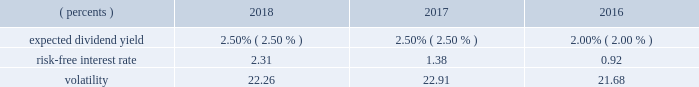Shareholder value award program svas are granted to officers and management and are payable in shares of our common stock .
The number of shares actually issued , if any , varies depending on our stock price at the end of the three-year vesting period compared to pre-established target stock prices .
We measure the fair value of the sva unit on the grant date using a monte carlo simulation model .
The model utilizes multiple input variables that determine the probability of satisfying the market condition stipulated in the award grant and calculates the fair value of the award .
Expected volatilities utilized in the model are based on implied volatilities from traded options on our stock , historical volatility of our stock price , and other factors .
Similarly , the dividend yield is based on historical experience and our estimate of future dividend yields .
The risk-free interest rate is derived from the u.s .
Treasury yield curve in effect at the time of grant .
The weighted-average fair values of the sva units granted during the years ended december 31 , 2018 , 2017 , and 2016 were $ 48.51 , $ 66.25 , and $ 48.68 , respectively , determined using the following assumptions: .
Pursuant to this program , approximately 0.7 million shares , 1.1 million shares , and 1.0 million shares were issued during the years ended december 31 , 2018 , 2017 , and 2016 , respectively .
Approximately 1.0 million shares are expected to be issued in 2019 .
As of december 31 , 2018 , the total remaining unrecognized compensation cost related to nonvested svas was $ 55.7 million , which will be amortized over the weighted-average remaining requisite service period of 20 months .
Restricted stock units rsus are granted to certain employees and are payable in shares of our common stock .
Rsu shares are accounted for at fair value based upon the closing stock price on the date of grant .
The corresponding expense is amortized over the vesting period , typically three years .
The fair values of rsu awards granted during the years ended december 31 , 2018 , 2017 , and 2016 were $ 70.95 , $ 72.47 , and $ 71.46 , respectively .
The number of shares ultimately issued for the rsu program remains constant with the exception of forfeitures .
Pursuant to this program , 1.3 million , 1.4 million , and 1.3 million shares were granted and approximately 1.0 million , 0.9 million , and 0.6 million shares were issued during the years ended december 31 , 2018 , 2017 , and 2016 , respectively .
Approximately 0.8 million shares are expected to be issued in 2019 .
As of december 31 , 2018 , the total remaining unrecognized compensation cost related to nonvested rsus was $ 112.2 million , which will be amortized over the weighted- average remaining requisite service period of 21 months .
Note 12 : shareholders' equity during 2018 , 2017 , and 2016 , we repurchased $ 4.15 billion , $ 359.8 million and $ 540.1 million , respectively , of shares associated with our share repurchase programs .
A payment of $ 60.0 million was made in 2016 for shares repurchased in 2017 .
During 2018 , we repurchased $ 2.05 billion of shares , which completed the $ 5.00 billion share repurchase program announced in october 2013 and our board authorized an $ 8.00 billion share repurchase program .
There were $ 2.10 billion repurchased under the $ 8.00 billion program in 2018 .
As of december 31 , 2018 , there were $ 5.90 billion of shares remaining under the 2018 program .
We have 5.0 million authorized shares of preferred stock .
As of december 31 , 2018 and 2017 , no preferred stock was issued .
We have an employee benefit trust that held 50.0 million shares of our common stock at both december 31 , 2018 and 2017 , to provide a source of funds to assist us in meeting our obligations under various employee benefit plans .
The cost basis of the shares held in the trust was $ 3.01 billion at both december 31 , 2018 and 2017 , and is shown as a reduction of shareholders 2019 equity .
Any dividend transactions between us and the trust are eliminated .
Stock held by the trust is not considered outstanding in the computation of eps .
The assets of the trust were not used to fund any of our obligations under these employee benefit plans during the years ended december 31 , 2018 , 2017 , and .
What was the percent of the change in the fair values of rsu awards granted from 2016 to 2017? 
Rationale: the percent of the change in the fair values of rsu awards granted from 2016 to 2017 was 1.4%
Computations: (1.1 / 71.46)
Answer: 0.01539. Shareholder value award program svas are granted to officers and management and are payable in shares of our common stock .
The number of shares actually issued , if any , varies depending on our stock price at the end of the three-year vesting period compared to pre-established target stock prices .
We measure the fair value of the sva unit on the grant date using a monte carlo simulation model .
The model utilizes multiple input variables that determine the probability of satisfying the market condition stipulated in the award grant and calculates the fair value of the award .
Expected volatilities utilized in the model are based on implied volatilities from traded options on our stock , historical volatility of our stock price , and other factors .
Similarly , the dividend yield is based on historical experience and our estimate of future dividend yields .
The risk-free interest rate is derived from the u.s .
Treasury yield curve in effect at the time of grant .
The weighted-average fair values of the sva units granted during the years ended december 31 , 2018 , 2017 , and 2016 were $ 48.51 , $ 66.25 , and $ 48.68 , respectively , determined using the following assumptions: .
Pursuant to this program , approximately 0.7 million shares , 1.1 million shares , and 1.0 million shares were issued during the years ended december 31 , 2018 , 2017 , and 2016 , respectively .
Approximately 1.0 million shares are expected to be issued in 2019 .
As of december 31 , 2018 , the total remaining unrecognized compensation cost related to nonvested svas was $ 55.7 million , which will be amortized over the weighted-average remaining requisite service period of 20 months .
Restricted stock units rsus are granted to certain employees and are payable in shares of our common stock .
Rsu shares are accounted for at fair value based upon the closing stock price on the date of grant .
The corresponding expense is amortized over the vesting period , typically three years .
The fair values of rsu awards granted during the years ended december 31 , 2018 , 2017 , and 2016 were $ 70.95 , $ 72.47 , and $ 71.46 , respectively .
The number of shares ultimately issued for the rsu program remains constant with the exception of forfeitures .
Pursuant to this program , 1.3 million , 1.4 million , and 1.3 million shares were granted and approximately 1.0 million , 0.9 million , and 0.6 million shares were issued during the years ended december 31 , 2018 , 2017 , and 2016 , respectively .
Approximately 0.8 million shares are expected to be issued in 2019 .
As of december 31 , 2018 , the total remaining unrecognized compensation cost related to nonvested rsus was $ 112.2 million , which will be amortized over the weighted- average remaining requisite service period of 21 months .
Note 12 : shareholders' equity during 2018 , 2017 , and 2016 , we repurchased $ 4.15 billion , $ 359.8 million and $ 540.1 million , respectively , of shares associated with our share repurchase programs .
A payment of $ 60.0 million was made in 2016 for shares repurchased in 2017 .
During 2018 , we repurchased $ 2.05 billion of shares , which completed the $ 5.00 billion share repurchase program announced in october 2013 and our board authorized an $ 8.00 billion share repurchase program .
There were $ 2.10 billion repurchased under the $ 8.00 billion program in 2018 .
As of december 31 , 2018 , there were $ 5.90 billion of shares remaining under the 2018 program .
We have 5.0 million authorized shares of preferred stock .
As of december 31 , 2018 and 2017 , no preferred stock was issued .
We have an employee benefit trust that held 50.0 million shares of our common stock at both december 31 , 2018 and 2017 , to provide a source of funds to assist us in meeting our obligations under various employee benefit plans .
The cost basis of the shares held in the trust was $ 3.01 billion at both december 31 , 2018 and 2017 , and is shown as a reduction of shareholders 2019 equity .
Any dividend transactions between us and the trust are eliminated .
Stock held by the trust is not considered outstanding in the computation of eps .
The assets of the trust were not used to fund any of our obligations under these employee benefit plans during the years ended december 31 , 2018 , 2017 , and .
What was the percentage change in dollars spent on share repurchase between 2016 and 2017? 
Computations: ((359.8 - 540.1) / 540.1)
Answer: -0.33383. Shareholder value award program svas are granted to officers and management and are payable in shares of our common stock .
The number of shares actually issued , if any , varies depending on our stock price at the end of the three-year vesting period compared to pre-established target stock prices .
We measure the fair value of the sva unit on the grant date using a monte carlo simulation model .
The model utilizes multiple input variables that determine the probability of satisfying the market condition stipulated in the award grant and calculates the fair value of the award .
Expected volatilities utilized in the model are based on implied volatilities from traded options on our stock , historical volatility of our stock price , and other factors .
Similarly , the dividend yield is based on historical experience and our estimate of future dividend yields .
The risk-free interest rate is derived from the u.s .
Treasury yield curve in effect at the time of grant .
The weighted-average fair values of the sva units granted during the years ended december 31 , 2018 , 2017 , and 2016 were $ 48.51 , $ 66.25 , and $ 48.68 , respectively , determined using the following assumptions: .
Pursuant to this program , approximately 0.7 million shares , 1.1 million shares , and 1.0 million shares were issued during the years ended december 31 , 2018 , 2017 , and 2016 , respectively .
Approximately 1.0 million shares are expected to be issued in 2019 .
As of december 31 , 2018 , the total remaining unrecognized compensation cost related to nonvested svas was $ 55.7 million , which will be amortized over the weighted-average remaining requisite service period of 20 months .
Restricted stock units rsus are granted to certain employees and are payable in shares of our common stock .
Rsu shares are accounted for at fair value based upon the closing stock price on the date of grant .
The corresponding expense is amortized over the vesting period , typically three years .
The fair values of rsu awards granted during the years ended december 31 , 2018 , 2017 , and 2016 were $ 70.95 , $ 72.47 , and $ 71.46 , respectively .
The number of shares ultimately issued for the rsu program remains constant with the exception of forfeitures .
Pursuant to this program , 1.3 million , 1.4 million , and 1.3 million shares were granted and approximately 1.0 million , 0.9 million , and 0.6 million shares were issued during the years ended december 31 , 2018 , 2017 , and 2016 , respectively .
Approximately 0.8 million shares are expected to be issued in 2019 .
As of december 31 , 2018 , the total remaining unrecognized compensation cost related to nonvested rsus was $ 112.2 million , which will be amortized over the weighted- average remaining requisite service period of 21 months .
Note 12 : shareholders' equity during 2018 , 2017 , and 2016 , we repurchased $ 4.15 billion , $ 359.8 million and $ 540.1 million , respectively , of shares associated with our share repurchase programs .
A payment of $ 60.0 million was made in 2016 for shares repurchased in 2017 .
During 2018 , we repurchased $ 2.05 billion of shares , which completed the $ 5.00 billion share repurchase program announced in october 2013 and our board authorized an $ 8.00 billion share repurchase program .
There were $ 2.10 billion repurchased under the $ 8.00 billion program in 2018 .
As of december 31 , 2018 , there were $ 5.90 billion of shares remaining under the 2018 program .
We have 5.0 million authorized shares of preferred stock .
As of december 31 , 2018 and 2017 , no preferred stock was issued .
We have an employee benefit trust that held 50.0 million shares of our common stock at both december 31 , 2018 and 2017 , to provide a source of funds to assist us in meeting our obligations under various employee benefit plans .
The cost basis of the shares held in the trust was $ 3.01 billion at both december 31 , 2018 and 2017 , and is shown as a reduction of shareholders 2019 equity .
Any dividend transactions between us and the trust are eliminated .
Stock held by the trust is not considered outstanding in the computation of eps .
The assets of the trust were not used to fund any of our obligations under these employee benefit plans during the years ended december 31 , 2018 , 2017 , and .
What was the percent of the change in the volatility from 2016 to 2017? 
Rationale: the change in the volatility from 2016 to 2017 was 1.1%
Computations: ((22.91 - 21.68) / 21.68)
Answer: 0.05673. 